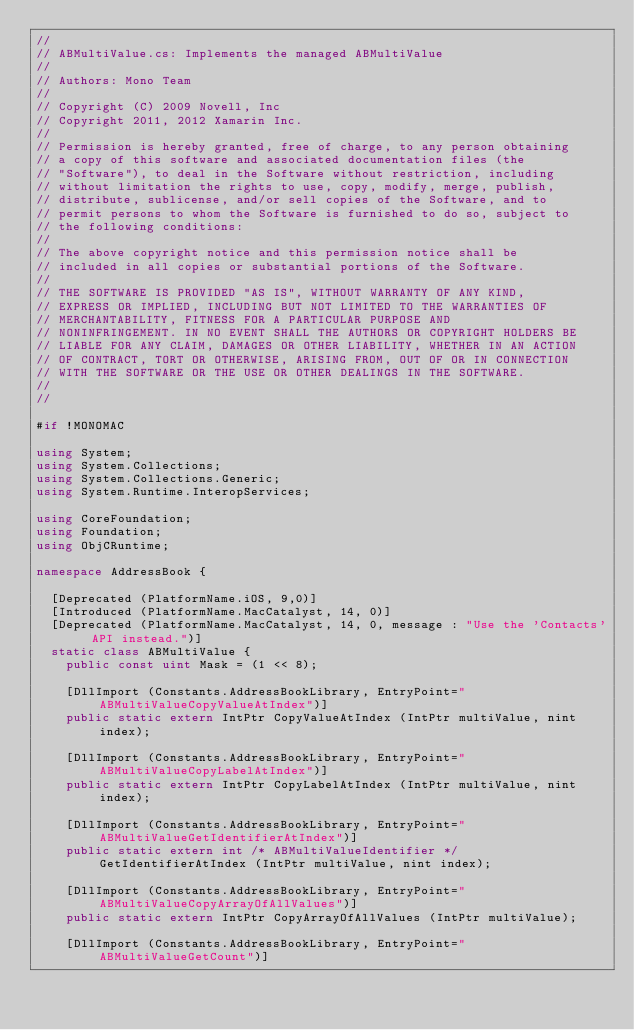<code> <loc_0><loc_0><loc_500><loc_500><_C#_>// 
// ABMultiValue.cs: Implements the managed ABMultiValue
//
// Authors: Mono Team
//     
// Copyright (C) 2009 Novell, Inc
// Copyright 2011, 2012 Xamarin Inc.
//
// Permission is hereby granted, free of charge, to any person obtaining
// a copy of this software and associated documentation files (the
// "Software"), to deal in the Software without restriction, including
// without limitation the rights to use, copy, modify, merge, publish,
// distribute, sublicense, and/or sell copies of the Software, and to
// permit persons to whom the Software is furnished to do so, subject to
// the following conditions:
// 
// The above copyright notice and this permission notice shall be
// included in all copies or substantial portions of the Software.
// 
// THE SOFTWARE IS PROVIDED "AS IS", WITHOUT WARRANTY OF ANY KIND,
// EXPRESS OR IMPLIED, INCLUDING BUT NOT LIMITED TO THE WARRANTIES OF
// MERCHANTABILITY, FITNESS FOR A PARTICULAR PURPOSE AND
// NONINFRINGEMENT. IN NO EVENT SHALL THE AUTHORS OR COPYRIGHT HOLDERS BE
// LIABLE FOR ANY CLAIM, DAMAGES OR OTHER LIABILITY, WHETHER IN AN ACTION
// OF CONTRACT, TORT OR OTHERWISE, ARISING FROM, OUT OF OR IN CONNECTION
// WITH THE SOFTWARE OR THE USE OR OTHER DEALINGS IN THE SOFTWARE.
//
//

#if !MONOMAC

using System;
using System.Collections;
using System.Collections.Generic;
using System.Runtime.InteropServices;

using CoreFoundation;
using Foundation;
using ObjCRuntime;

namespace AddressBook {

	[Deprecated (PlatformName.iOS, 9,0)]
	[Introduced (PlatformName.MacCatalyst, 14, 0)]
	[Deprecated (PlatformName.MacCatalyst, 14, 0, message : "Use the 'Contacts' API instead.")]
	static class ABMultiValue {
		public const uint Mask = (1 << 8);

		[DllImport (Constants.AddressBookLibrary, EntryPoint="ABMultiValueCopyValueAtIndex")]
		public static extern IntPtr CopyValueAtIndex (IntPtr multiValue, nint index);

		[DllImport (Constants.AddressBookLibrary, EntryPoint="ABMultiValueCopyLabelAtIndex")]
		public static extern IntPtr CopyLabelAtIndex (IntPtr multiValue, nint index);

		[DllImport (Constants.AddressBookLibrary, EntryPoint="ABMultiValueGetIdentifierAtIndex")]
		public static extern int /* ABMultiValueIdentifier */ GetIdentifierAtIndex (IntPtr multiValue, nint index);

		[DllImport (Constants.AddressBookLibrary, EntryPoint="ABMultiValueCopyArrayOfAllValues")]
		public static extern IntPtr CopyArrayOfAllValues (IntPtr multiValue);

		[DllImport (Constants.AddressBookLibrary, EntryPoint="ABMultiValueGetCount")]</code> 